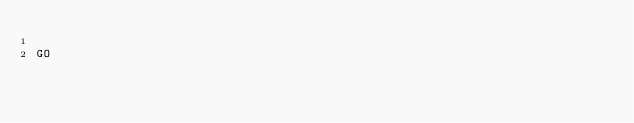<code> <loc_0><loc_0><loc_500><loc_500><_SQL_>
GO</code> 